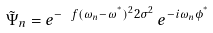<formula> <loc_0><loc_0><loc_500><loc_500>\tilde { \Psi } _ { n } = e ^ { - \ f { ( \omega _ { n } - \omega ^ { ^ { * } } ) ^ { 2 } } { 2 \sigma ^ { 2 } } } \, e ^ { - i \omega _ { n } \phi ^ { ^ { * } } }</formula> 